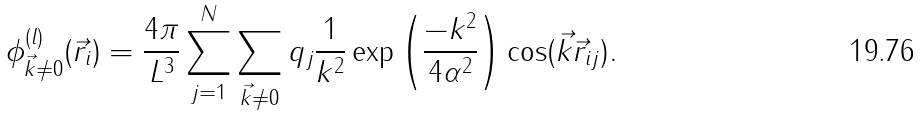Convert formula to latex. <formula><loc_0><loc_0><loc_500><loc_500>\phi _ { \vec { k } \neq 0 } ^ { ( l ) } ( \vec { r } _ { i } ) = \frac { 4 \pi } { L ^ { 3 } } \sum _ { j = 1 } ^ { N } \sum _ { \vec { k } \neq 0 } q _ { j } \frac { 1 } { k ^ { 2 } } \exp \left ( \frac { - k ^ { 2 } } { 4 \alpha ^ { 2 } } \right ) \cos ( \vec { k } \vec { r } _ { i j } ) .</formula> 